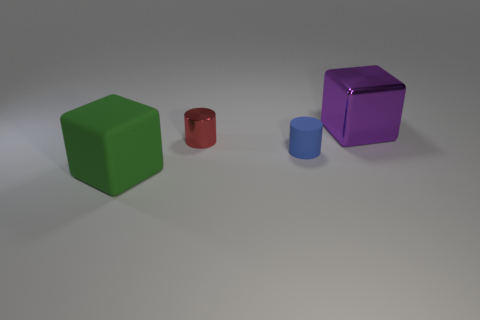There is a purple metallic thing that is the same size as the rubber cube; what is its shape?
Keep it short and to the point. Cube. There is a metal object that is in front of the big object that is to the right of the green matte object; what number of big blocks are to the left of it?
Your response must be concise. 1. Is the number of green rubber cubes behind the large purple object greater than the number of blue matte objects on the left side of the large rubber object?
Provide a short and direct response. No. What number of green rubber things have the same shape as the purple shiny thing?
Keep it short and to the point. 1. How many things are either rubber things behind the large green matte block or large things that are behind the big green matte cube?
Ensure brevity in your answer.  2. There is a cube in front of the large purple cube that is behind the rubber thing behind the large green rubber block; what is it made of?
Keep it short and to the point. Rubber. Does the cube behind the big green block have the same color as the rubber block?
Your answer should be very brief. No. There is a object that is both to the right of the red shiny cylinder and in front of the big purple cube; what material is it?
Give a very brief answer. Rubber. Is there a green matte cube that has the same size as the purple shiny object?
Offer a very short reply. Yes. What number of tiny things are there?
Your answer should be compact. 2. 